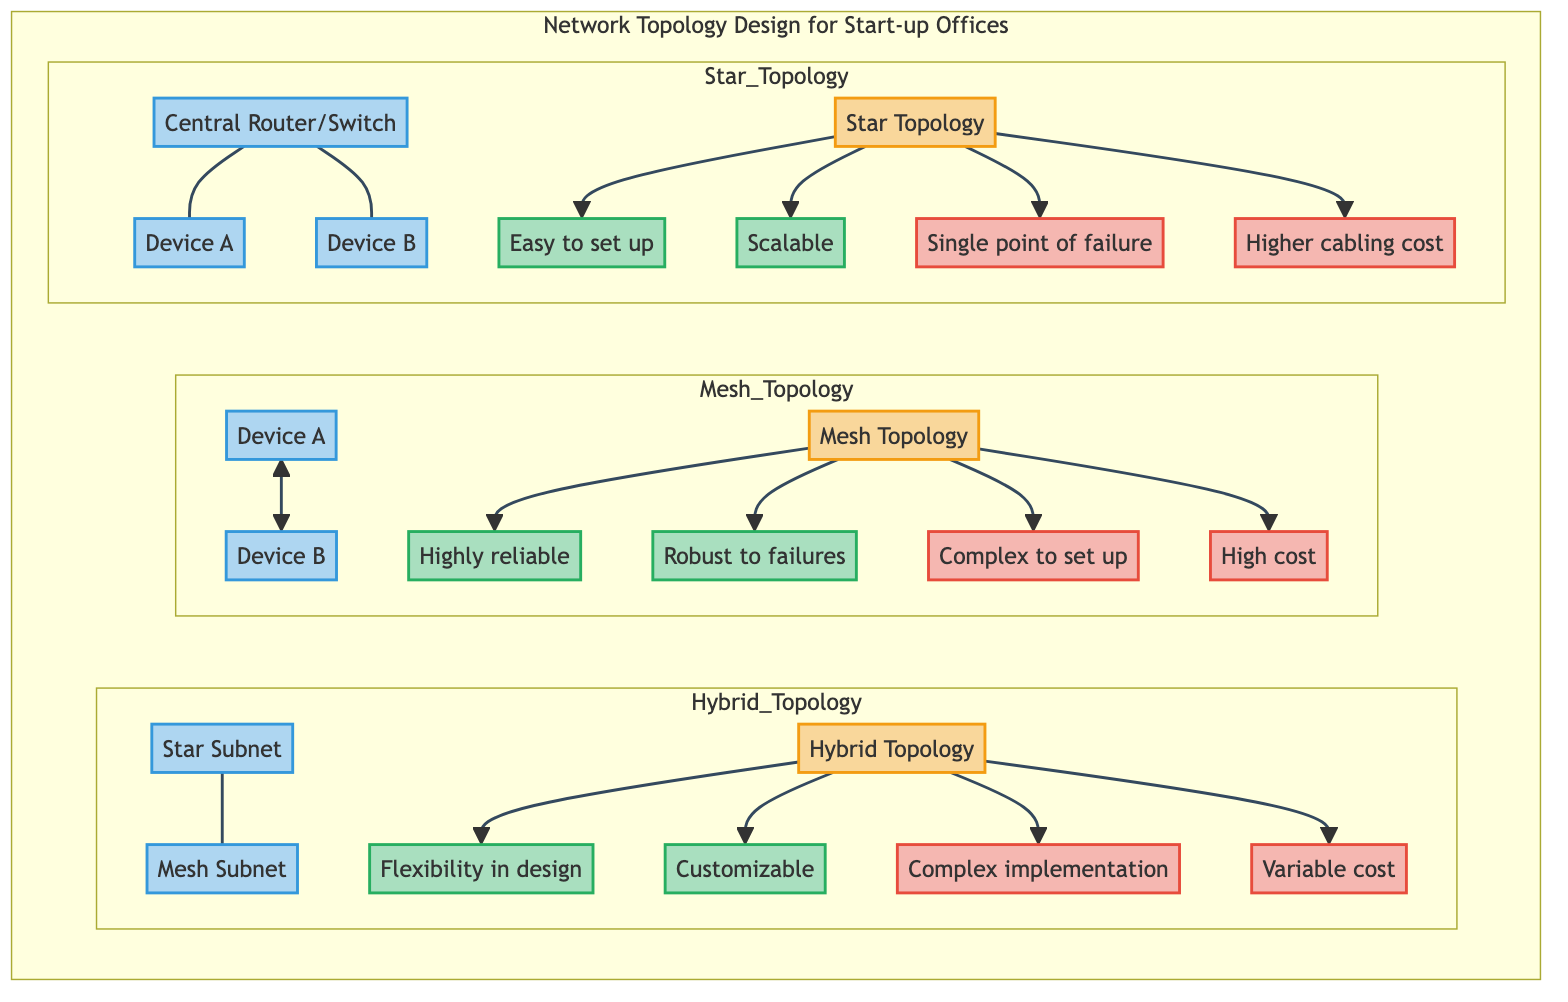What is the central device in the Star Topology? The Star Topology includes a Central Router or Switch represented by the node labeled "Central Router/Switch." This is the device that connects all other devices in the star configuration.
Answer: Central Router/Switch How many advantages are listed for the Mesh Topology? The Mesh Topology node is connected to two advantages, labeled "Highly reliable" and "Robust to failures." This indicates that there are two positive aspects associated with this topology.
Answer: 2 What is one disadvantage of the Hybrid Topology? The Hybrid Topology has two disadvantages listed: "Complex implementation" and "Variable cost." Out of these, either could answer the question, but one specific disadvantage mentioned is "Complex implementation."
Answer: Complex implementation Which topology has a higher cabling cost? In the diagram, under Star Topology, it specifically states "Higher cabling cost" as one of its disadvantages, indicating that compared to others, this topology incurs more cost in cabling.
Answer: Higher cabling cost What type of topology is characterized by flexibility in design? The Hybrid Topology features the advantage labeled "Flexibility in design," indicating that this topology allows for various design configurations according to specific needs.
Answer: Hybrid Topology What is the relationship between Device A and Device B in the Mesh Topology? The relationship between Device A and Device B in the Mesh Topology is represented with a bi-directional line indicating a direct connection, which characterizes the interconnectivity of the devices in this configuration.
Answer: Direct connection How many total topologies are presented in the diagram? The diagram presents three types of network topologies: Star, Mesh, and Hybrid, which are explicitly labeled within their respective subgraphs.
Answer: 3 What is the disadvantage of the Star Topology related to failure? The Star Topology includes a disadvantage labeled "Single point of failure," which highlights that if the central device fails, the entire network can go down.
Answer: Single point of failure 